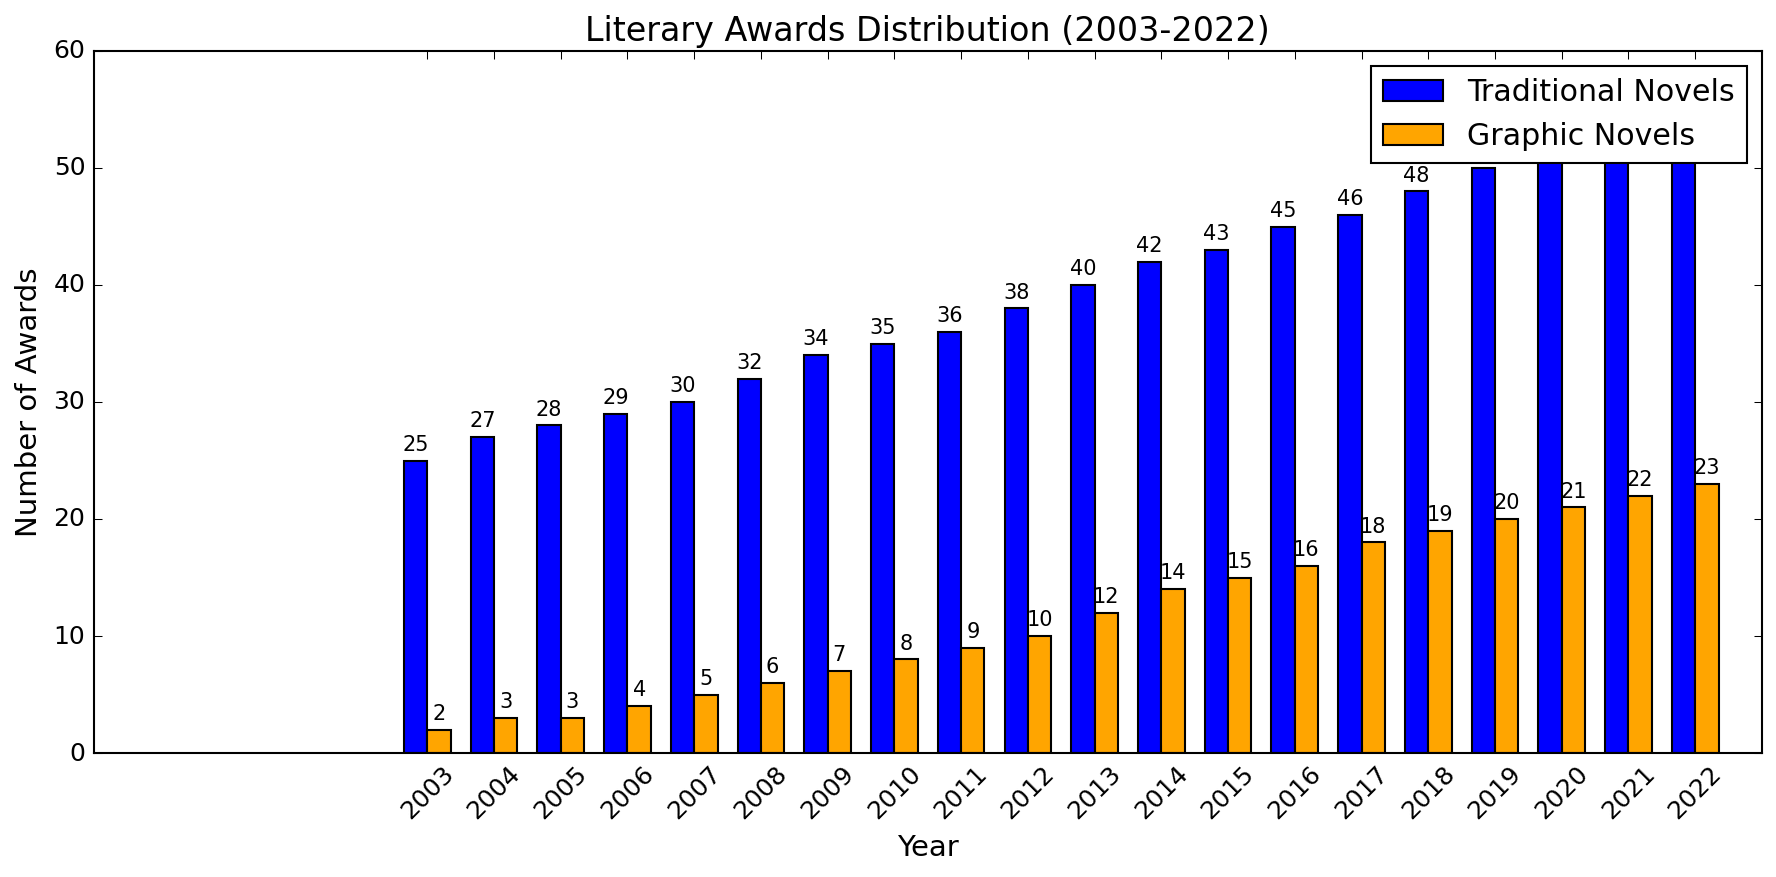What's the difference in the number of awards between traditional novels and graphic novels in 2022? To find the difference, subtract the number of awards for graphic novels from the number of awards for traditional novels for the year 2022. That is, 56 (traditional novels) - 23 (graphic novels) = 33.
Answer: 33 In which year did traditional novels first receive more than 40 awards? Identify the year where traditional novels surpassed 40 awards by analyzing the height of the blue bars. In 2013, traditional novels received 40 awards, and in 2014, the number is 42. So the first year they exceeded 40 awards is 2014.
Answer: 2014 What is the trend in the number of awards for graphic novels from 2003 to 2022? To analyze the trend, observe the orange bars for graphic novels over the years. The graph shows a steady increase in the number of awards for graphic novels from 2 in 2003 to 23 in 2022, indicating a positive trend.
Answer: Positive trend By how much did the number of awards for traditional novels increase from 2010 to 2020? First, identify the number of awards for traditional novels in 2010, which is 35. Then, find the number for 2020, which is 52. Subtract the 2010 value from the 2020 value: 52 - 35 = 17.
Answer: 17 In which year did graphic novels see the highest increase in the number of awards compared to the previous year? Compare the height of the orange bars year by year. The highest year-on-year increase is from 2013 to 2014, where the number of awards increased from 12 to 14, a change of 2 awards.
Answer: 2014 What was the percentage increase in the number of awards for traditional novels from 2003 to 2022? First, determine the initial value (2003, 25 awards) and the final value (2022, 56 awards). Calculate the increase: 56 - 25 = 31. Then, the percentage increase is (31 / 25) * 100% ≈ 124%.
Answer: 124% In which year did the awards for graphic novels reach double digits for the first time? Identify when the orange bars representing graphic novels reached 10 or more awards for the first time. This happened in 2012 when the number of awards reached 10.
Answer: 2012 How many total awards were given to graphic novels over the period of 2003 to 2022? Sum the values of graphic novels from each year: 2 + 3 + 3 + 4 + 5 + 6 + 7 + 8 + 9 + 10 + 12 + 14 + 15 + 16 + 18 + 19 + 20 + 21 + 22 + 23 = 237.
Answer: 237 